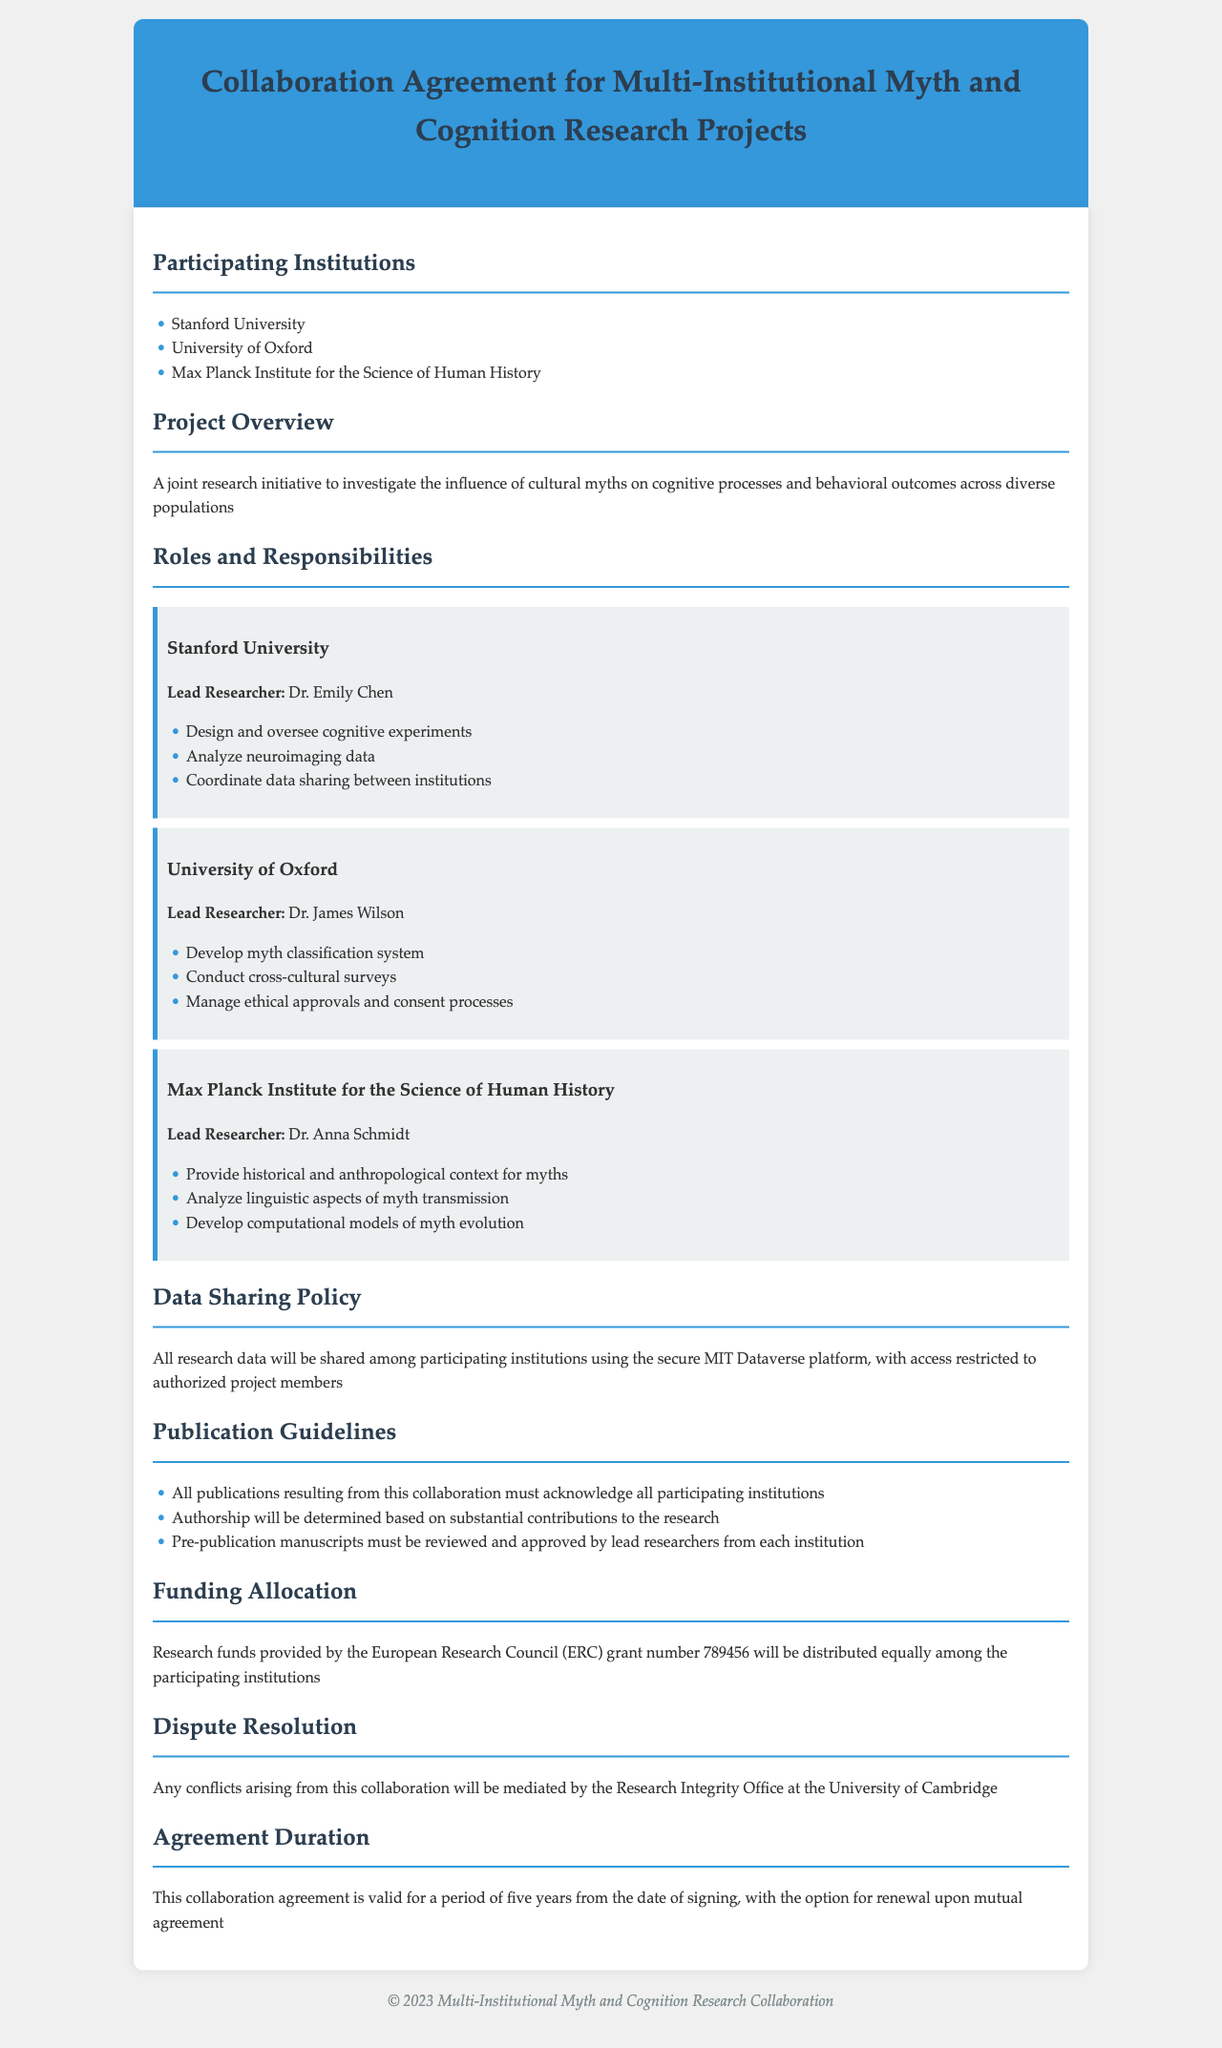What are the participating institutions? The document lists all institutions involved in the research collaboration, which are Stanford University, University of Oxford, and Max Planck Institute for the Science of Human History.
Answer: Stanford University, University of Oxford, Max Planck Institute for the Science of Human History Who is the lead researcher at Stanford University? The document specifies the lead researcher for each institution; for Stanford University, it is Dr. Emily Chen.
Answer: Dr. Emily Chen What is the grant number provided by the European Research Council? The document mentions the funding source and its specific grant number, which is needed for financial tracking and organization.
Answer: 789456 What data sharing platform is used? The policy outlines the method for data sharing and specifies that the MIT Dataverse platform is used.
Answer: MIT Dataverse How long is the collaboration agreement valid? The duration of the agreement is stated in the document as a specific time frame for which the agreement is effective.
Answer: Five years What is the role of the University of Oxford in this collaboration? The document describes the responsibilities of the University of Oxford, highlighting its specific role in the overall project.
Answer: Develop myth classification system, conduct cross-cultural surveys, manage ethical approvals and consent processes What is the dispute resolution mechanism in place? The document explicitly states the process for handling conflicts that may arise during the collaboration.
Answer: Research Integrity Office at the University of Cambridge How will authorship be determined for publications? The agreement outlines criteria for authorship and emphasizes contributions to the research for fair recognition.
Answer: Based on substantial contributions to the research 